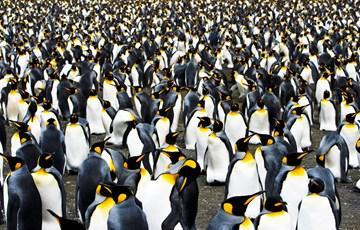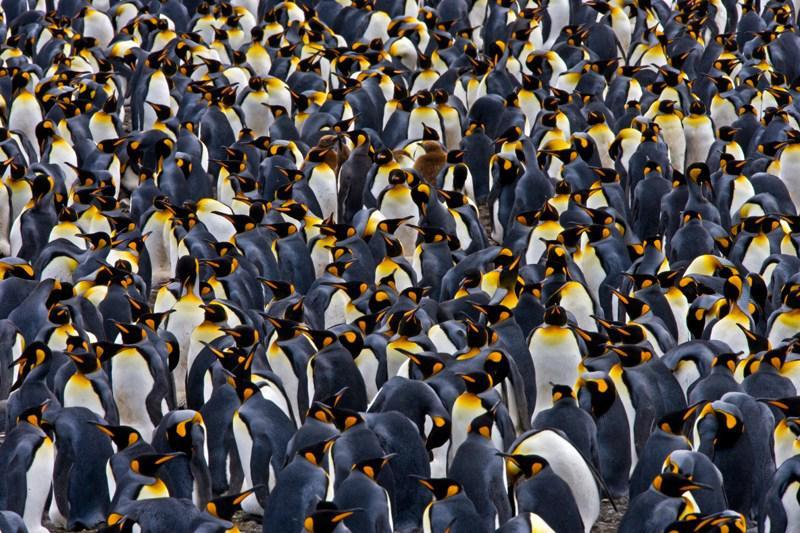The first image is the image on the left, the second image is the image on the right. For the images shown, is this caption "The ground is visible in the image on the right." true? Answer yes or no. No. 